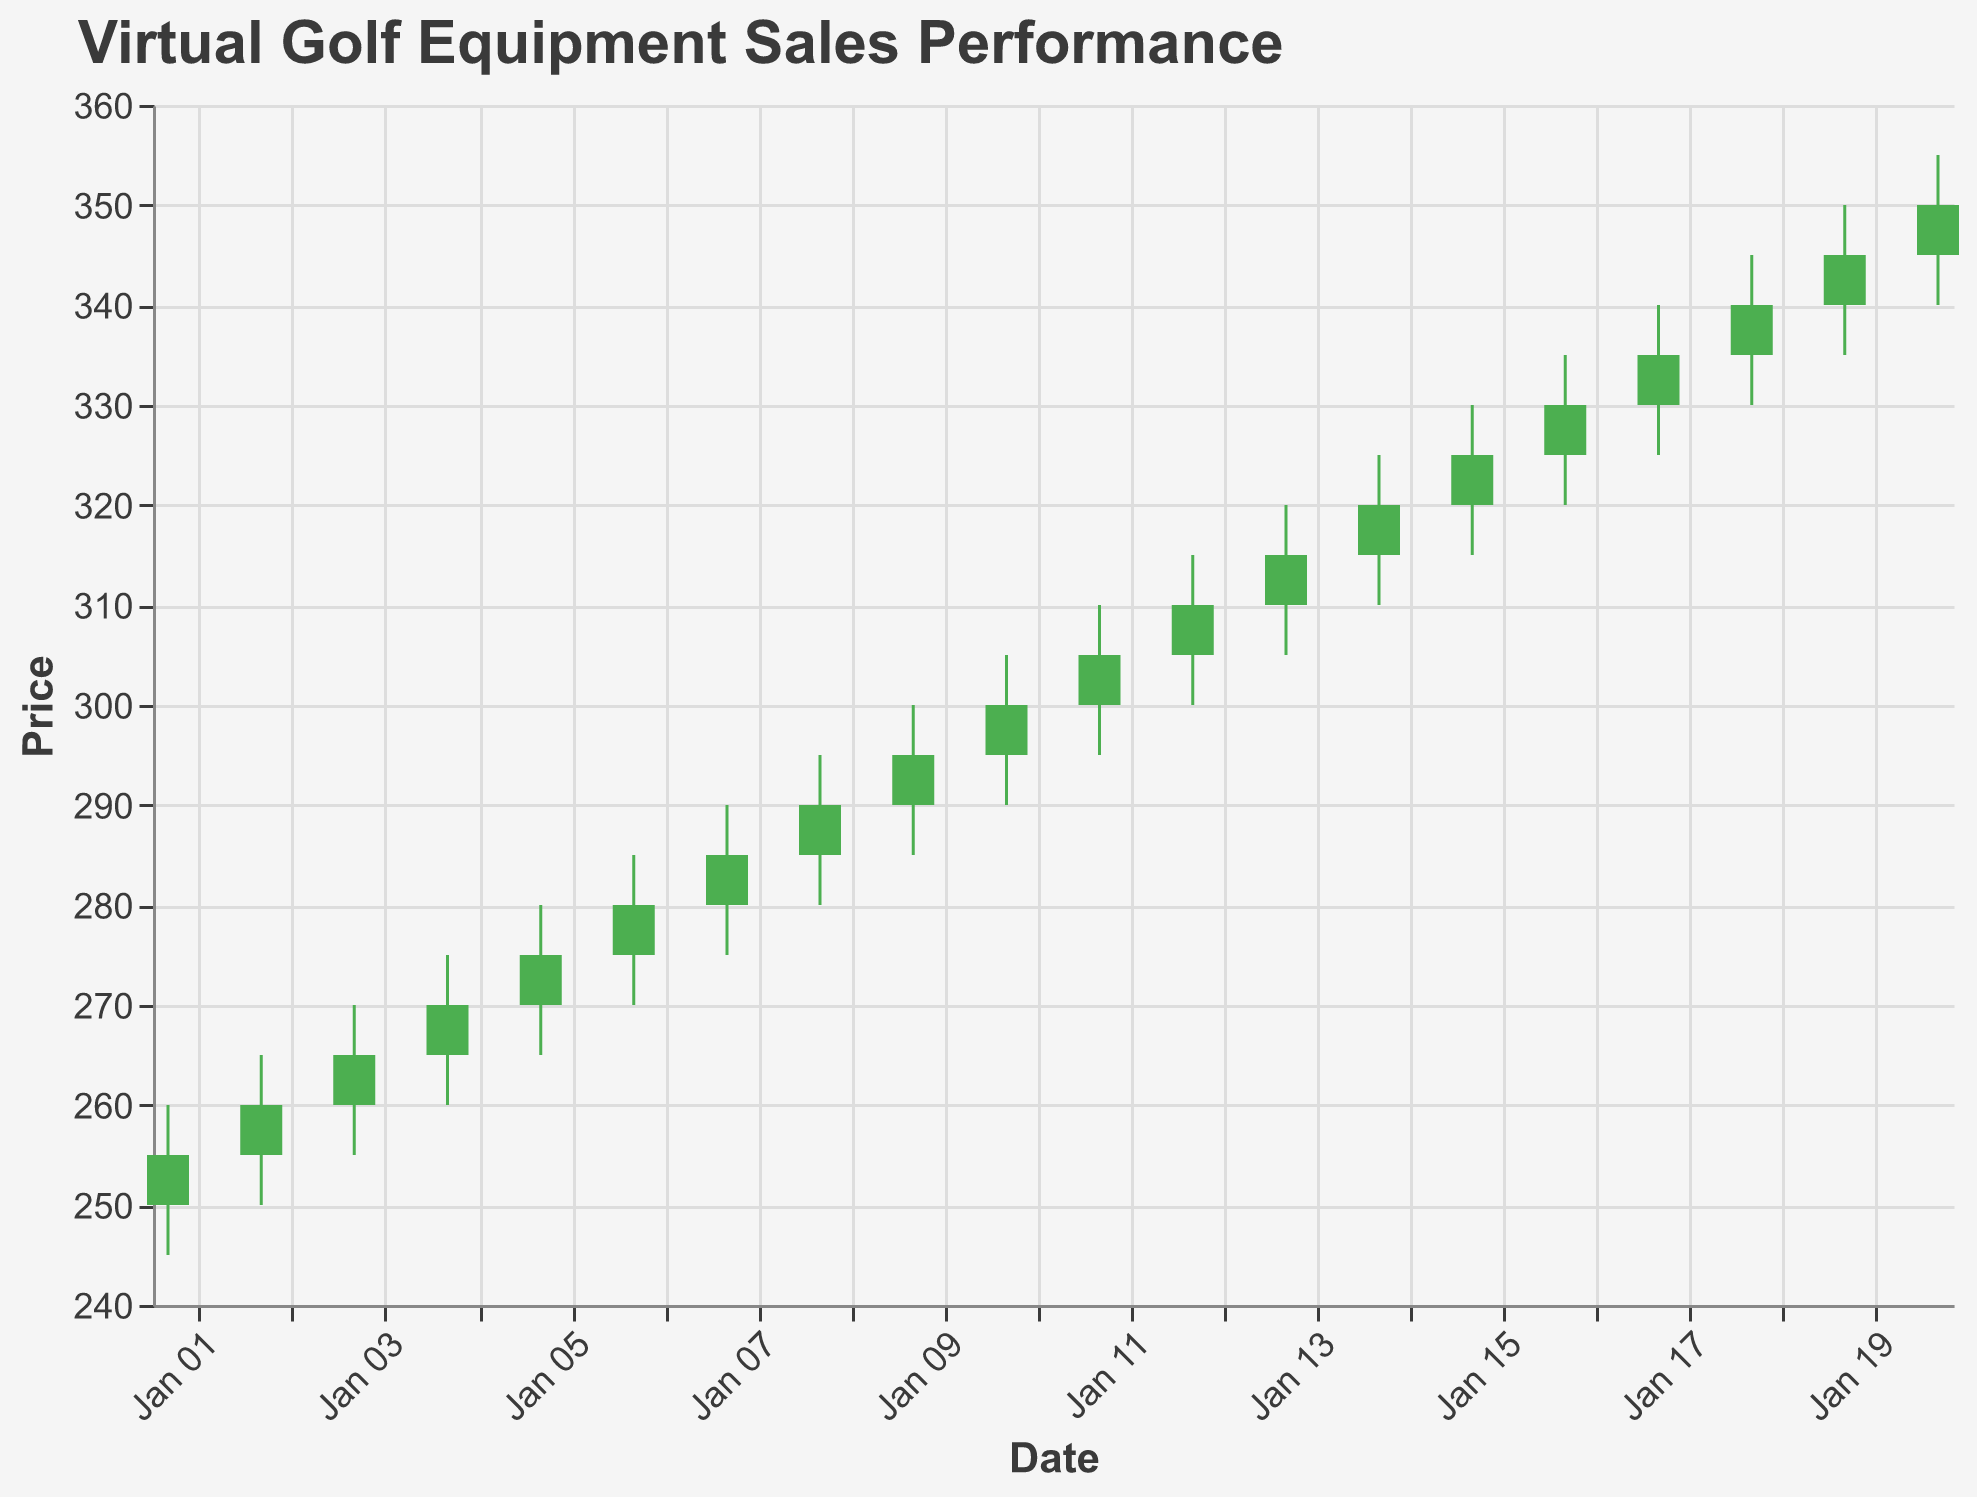What's the title of the figure? The title is typically found at the top of the figure. Here, it mentions the Quarterly Sales Performance of Virtual Golf Equipment specifically within the Sports Retail Market.
Answer: Virtual Golf Equipment Sales Performance What is the range of prices shown on the y-axis? The range of prices on the y-axis can be determined by looking at the axis markers. They show values from 240 to 360.
Answer: 240 to 360 On which date did the highest closing price occur? By examining the "Close" values for each date, it's clear that the closing prices are increasing. The highest closing price happens on the latest date given, which is 2023-01-20, where the price closes at 350.
Answer: 2023-01-20 What is the overall trend in the closing prices? To determine the overall trend, observe the series of closing prices over the dates. The closing prices are consistently increasing from 255 on 2023-01-01 to 350 on 2023-01-20, indicating a strong upward trend.
Answer: Increasing How many days had a closing price higher than its opening price? To find this, compare the "Open" and "Close" prices for each day. If "Close" is higher than "Open", the day had a higher closing price. This occurs on all days from 2023-01-01 to 2023-01-20. Hence, there are 20 days.
Answer: 20 days On what date did the lowest "Low" price occur and what was the price? The "Low" prices across each date need to be checked to identify the minimum value. The lowest "Low" price is 245, which occurred on 2023-01-01.
Answer: 2023-01-01, 245 What was the average closing price over the period? The average closing price is found by summing all closing prices and dividing by the number of days. The sum of closing prices is 5790. There are 20 days, so the average is 5790/20 = 289.5.
Answer: 289.5 How does the volume change over the period? To understand changes in volume, observe the "Volume" values for each date. The volume increases from 1200 on 2023-01-01 to 2200 on 2023-01-20, indicating a gradual increase in volume.
Answer: Increasing Which date experienced the highest single-day price increase from open to close? To identify the maximum single-day price increase, calculate the difference between "Close" and "Open" for each day and find the largest. The highest change is on 2023-01-01, with an increase of 5 (255 - 250).
Answer: 2023-01-01 What is the relationship between volume and closing price? By comparing the trends, as the closing price increases, the volume also tends to increase. This indicates a positive correlation between volume and closing price.
Answer: Positive correlation 